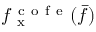Convert formula to latex. <formula><loc_0><loc_0><loc_500><loc_500>f _ { x } ^ { c o f e } ( \bar { f } )</formula> 